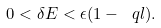Convert formula to latex. <formula><loc_0><loc_0><loc_500><loc_500>0 < \delta E < \epsilon ( 1 - \ q l ) .</formula> 